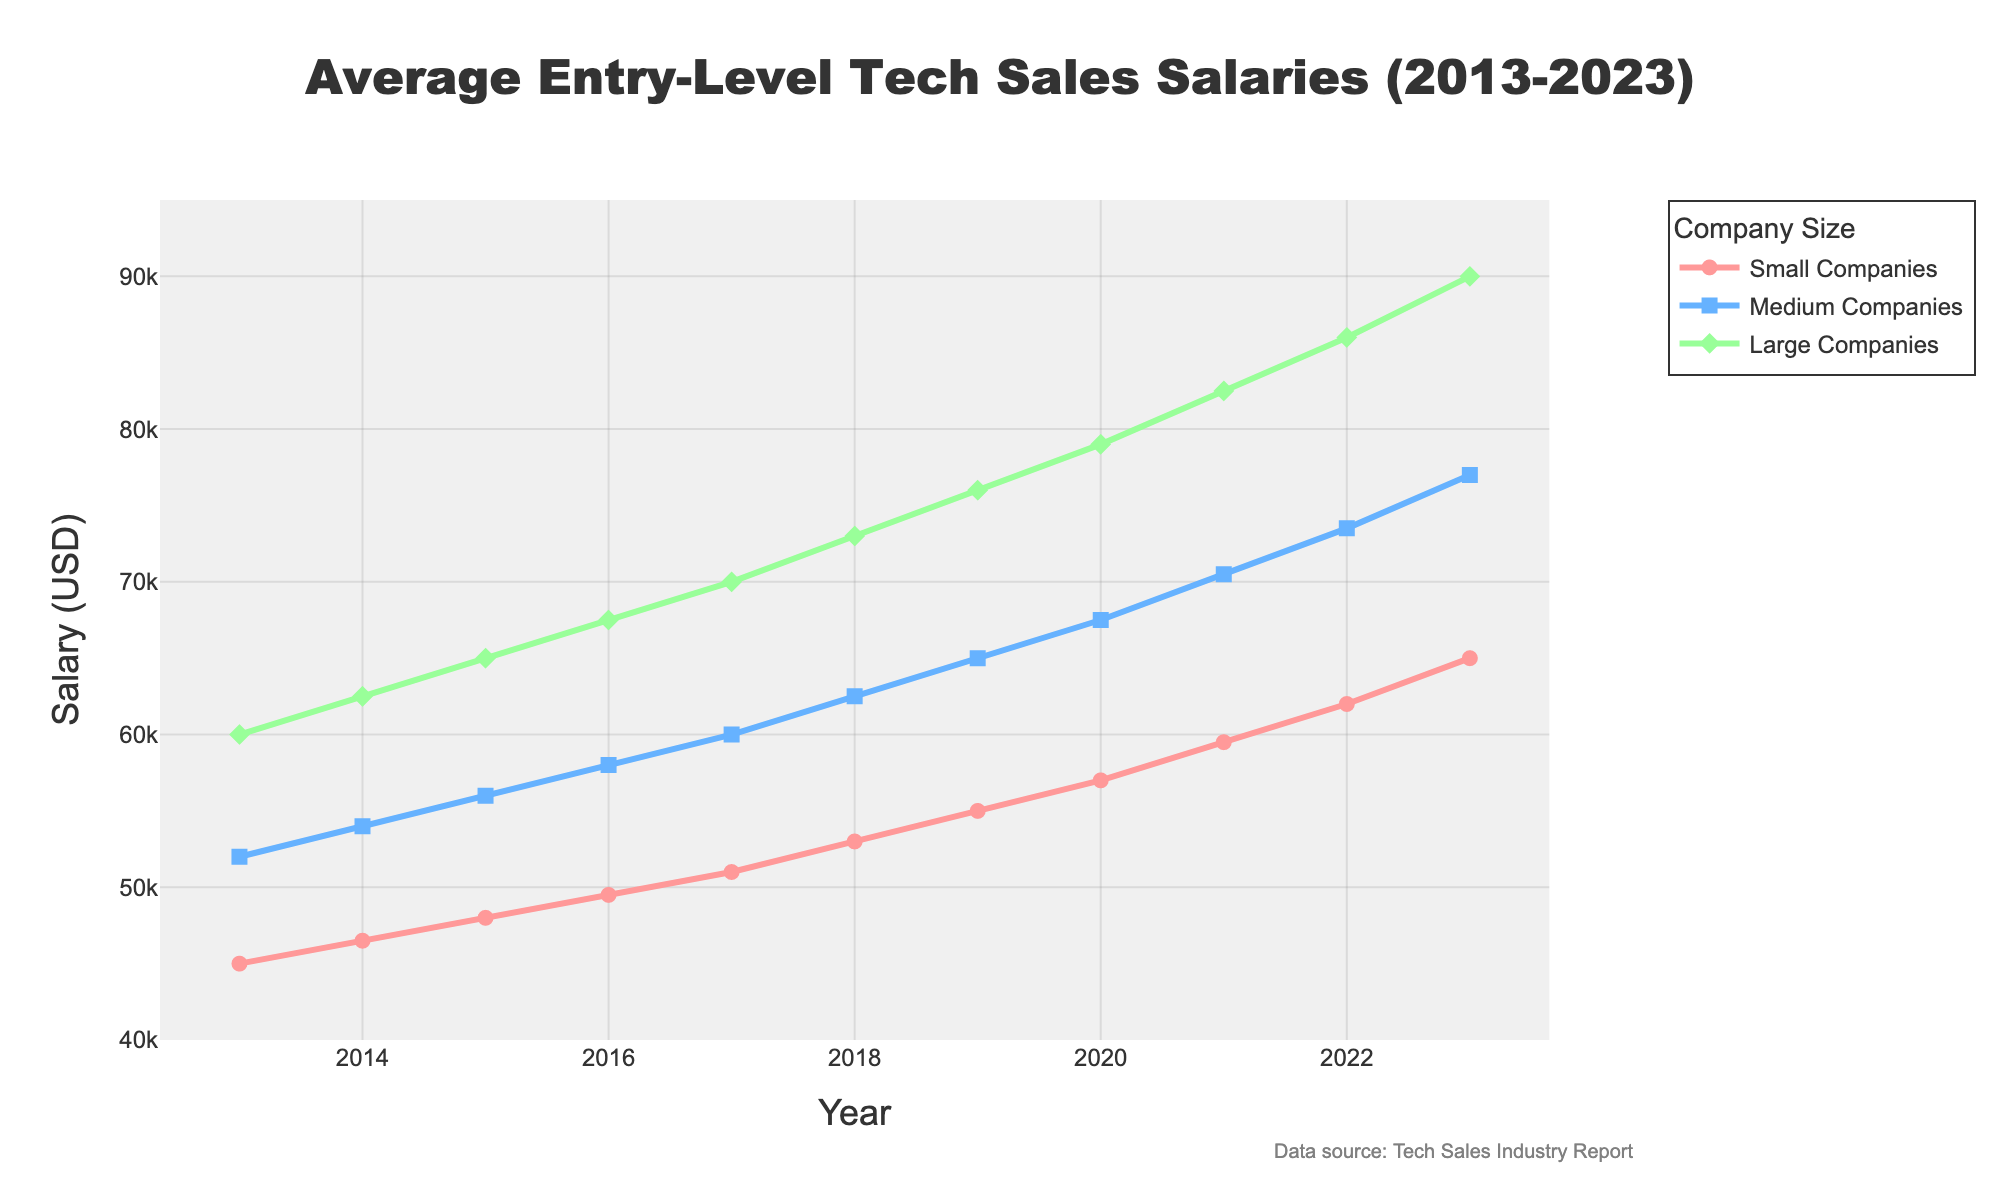What is the difference in salaries between small and large companies in 2023? The salary for small companies in 2023 is $65,000, and for large companies, it is $90,000. The difference is $90,000 - $65,000.
Answer: $25,000 Which company size had the highest salary increase from 2013 to 2023? Calculating the increase: Small companies went from $45,000 to $65,000, an increase of $20,000. Medium companies went from $52,000 to $77,000, an increase of $25,000. Large companies went from $60,000 to $90,000, an increase of $30,000. The highest increase was for large companies.
Answer: Large Companies Among all three company sizes, which one had the smallest salary in 2018? Looking at the data for 2018: Small companies had $53,000, medium had $62,500, and large had $73,000. The smallest salary is for small companies.
Answer: Small Companies By how much did the salary for medium companies change from 2015 to 2020? For medium companies: In 2015 the salary was $56,000, and in 2020 it was $67,500. The change is $67,500 - $56,000.
Answer: $11,500 In which year did small companies reach a salary of $50,000 or more? The salary for small companies reached $51,000 in 2017, which is the first year it hit $50,000 or more.
Answer: 2017 What is the average salary in 2023 across all company sizes? Sum the 2023 salaries: $65,000 (small) + $77,000 (medium) + $90,000 (large) = $232,000. Divide by 3 to find the average: $232,000 / 3.
Answer: $77,333 Which company size experienced the greatest annual salary growth between 2019 and 2020? Calculate the annual growth: For small companies $57,000 - $55,000 = $2,000. For medium companies $67,500 - $65,000 = $2,500. For large companies $79,000 - $76,000 = $3,000. The greatest growth was for large companies.
Answer: Large Companies What is the trend in salary for large companies from 2013 to 2023? The salary for large companies has consistently increased from $60,000 in 2013 to $90,000 in 2023, showing a positive trend.
Answer: Increasing Trend 